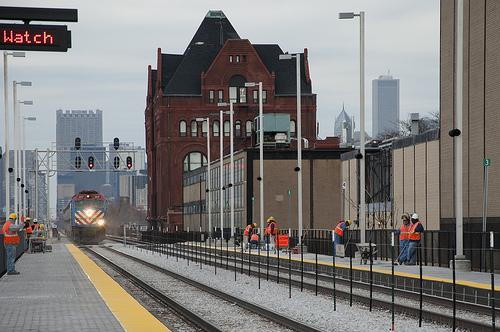Describe the interaction between the train and the surrounding environment. The train is arriving at the city train station, navigating along the tracks with its front light on, while workers stand on the platforms and various architectural and safety elements surround the train. Identify two different human-related objects in the image and describe their use or function. A red signal on a street light helps manage traffic flow, while street light fixtures on tall utility poles provide illumination during nighttime hours. Provide a count and description of people in the image based on their occupation and attire. There are railway workers wearing yellow helmets and orange high visibility vests standing on both platforms at the train station. What kind of location is depicted in the image and how can one identify it? The location is a city train station, identifiable by the train tracks, platforms, train signals, and workers in high visibility vests. In the image, how many sets of railroad tracks can be seen and what is notable about their surroundings? There are two sets of train tracks with barrier fencing in between, and black poles are visible between the tracks. Identify and briefly describe an architectural element in the image. A tall multistory city building, possibly being a skyscraper, can be seen in the background, characterized by its towering height and numerous windows. What does the presence of workers suggest about the situation at the train station? The presence of workers suggests that maintenance, repairs, or construction work might be happening at the train station. Identify the primary mode of transportation in the image and whether it's operational or not. The primary mode of transportation is a train, and the train's front light indicates that it's operational. Discuss the elements in the image that suggest it might be a construction site. The presence of workers in orange high visibility vests, a yellow helmet on a man, and an orange construction sign suggest it might be a construction site. Talk about a safety-related feature visible on the platform in the image. The solid yellow platform warning stripe serves as a safety feature, reminding passengers to stand back from the edge of the platform. Are the skyscrapers in the background made of glass? The material of the skyscrapers is not mentioned in the given informations, so assuming they are made of glass would be misleading. Is the train on the tracks green in color? There is no mention of the train's color in the given informations, so stating that it is green would be misleading. Is there a blue signal on the street light? The given information mentions a red signal on street light, and there is no mention of a blue signal making this instruction misleading. Are there trees next to the brick building? There is no mention of trees next to the brick building in the given information, so asking about trees is misleading. Is the yellow line on the platform curved? There is no mention of the yellow line being curved in the given information, stating that it is curved would be misleading. Is there a purple helmet on the man? The given information refers to a yellow helmet on the man, so asking about a purple helmet would be misleading. 